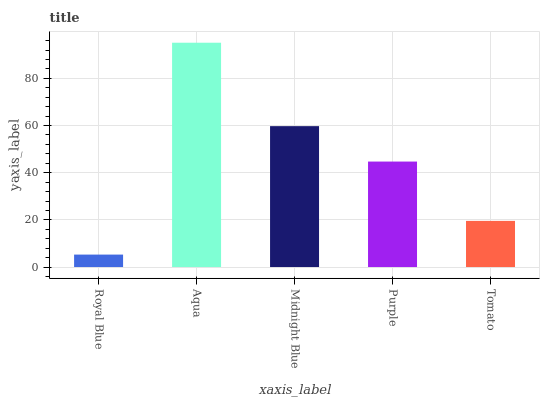Is Royal Blue the minimum?
Answer yes or no. Yes. Is Aqua the maximum?
Answer yes or no. Yes. Is Midnight Blue the minimum?
Answer yes or no. No. Is Midnight Blue the maximum?
Answer yes or no. No. Is Aqua greater than Midnight Blue?
Answer yes or no. Yes. Is Midnight Blue less than Aqua?
Answer yes or no. Yes. Is Midnight Blue greater than Aqua?
Answer yes or no. No. Is Aqua less than Midnight Blue?
Answer yes or no. No. Is Purple the high median?
Answer yes or no. Yes. Is Purple the low median?
Answer yes or no. Yes. Is Royal Blue the high median?
Answer yes or no. No. Is Tomato the low median?
Answer yes or no. No. 